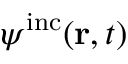Convert formula to latex. <formula><loc_0><loc_0><loc_500><loc_500>\psi ^ { i n c } ( { r } , t )</formula> 